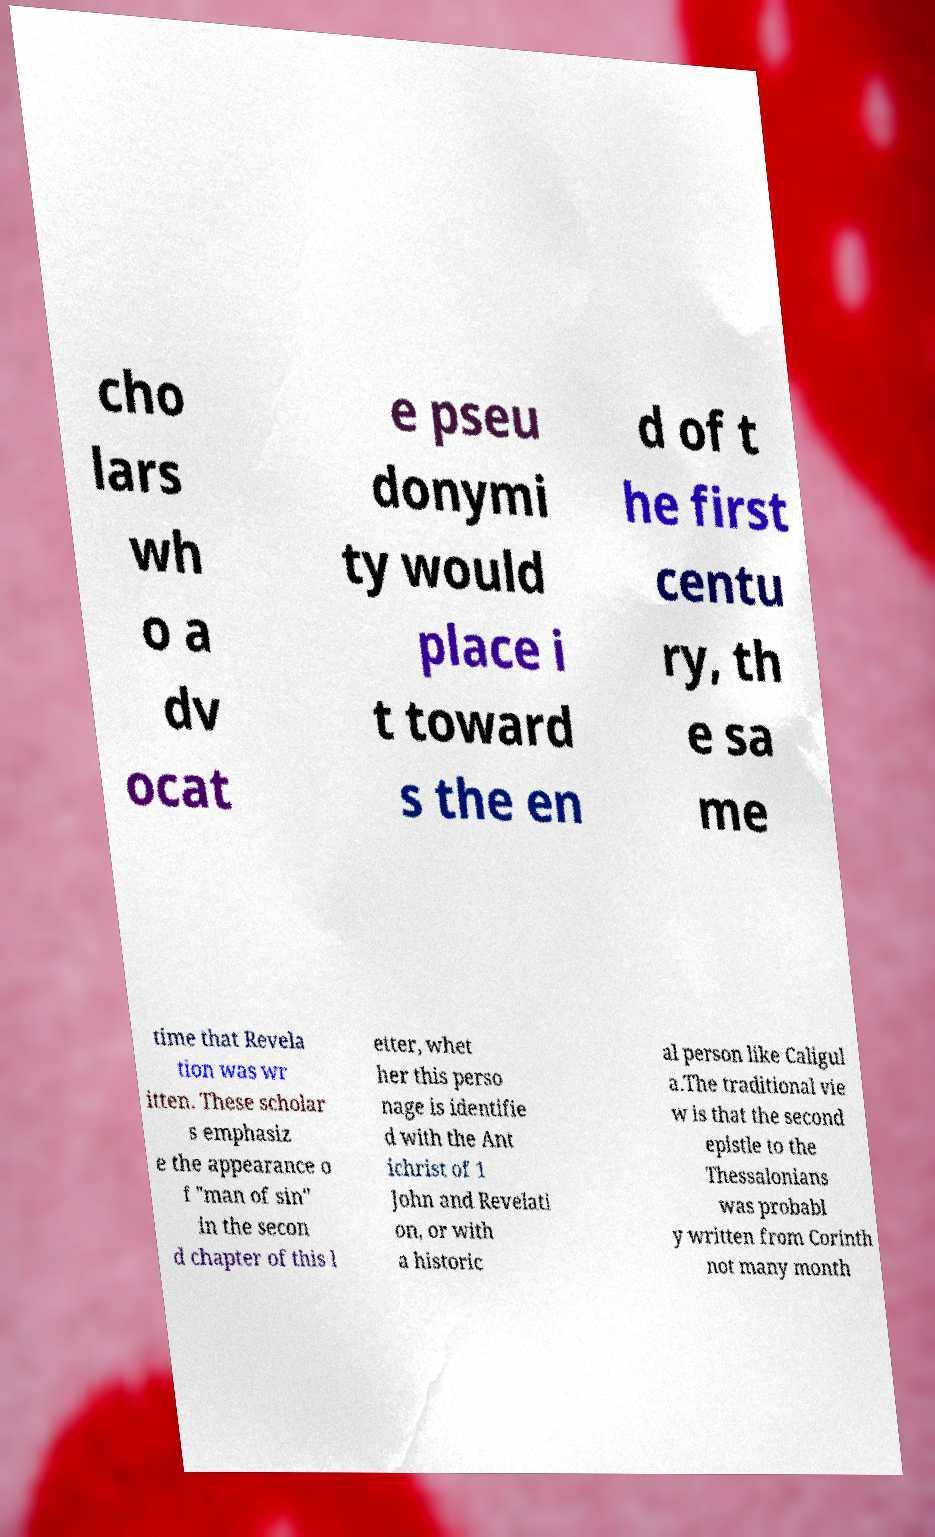Please read and relay the text visible in this image. What does it say? cho lars wh o a dv ocat e pseu donymi ty would place i t toward s the en d of t he first centu ry, th e sa me time that Revela tion was wr itten. These scholar s emphasiz e the appearance o f "man of sin" in the secon d chapter of this l etter, whet her this perso nage is identifie d with the Ant ichrist of 1 John and Revelati on, or with a historic al person like Caligul a.The traditional vie w is that the second epistle to the Thessalonians was probabl y written from Corinth not many month 